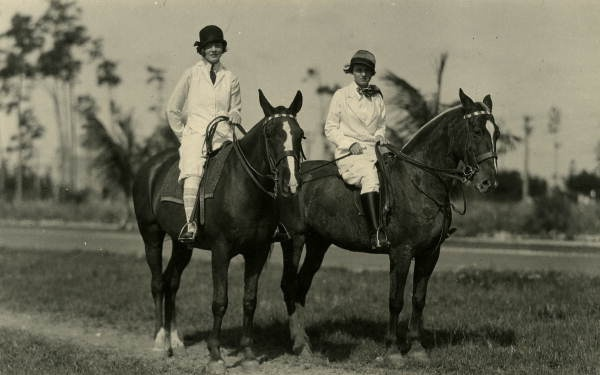Describe the objects in this image and their specific colors. I can see horse in beige, black, gray, and darkgray tones, horse in beige, black, gray, and darkgray tones, people in tan and black tones, people in beige, tan, darkgray, black, and gray tones, and tie in beige, black, gray, and darkgray tones in this image. 